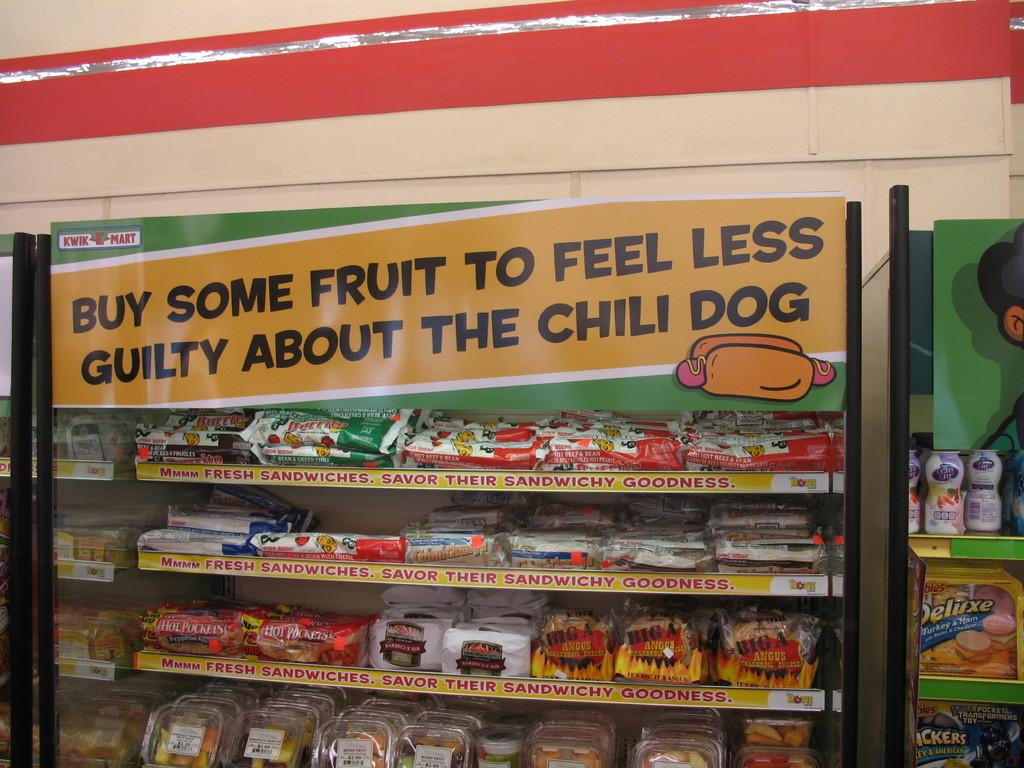Why do we buy some fruit?
Provide a succinct answer. To feel less guilty about the chili dog. What does the sign say to buy?
Your answer should be very brief. Fruit. 